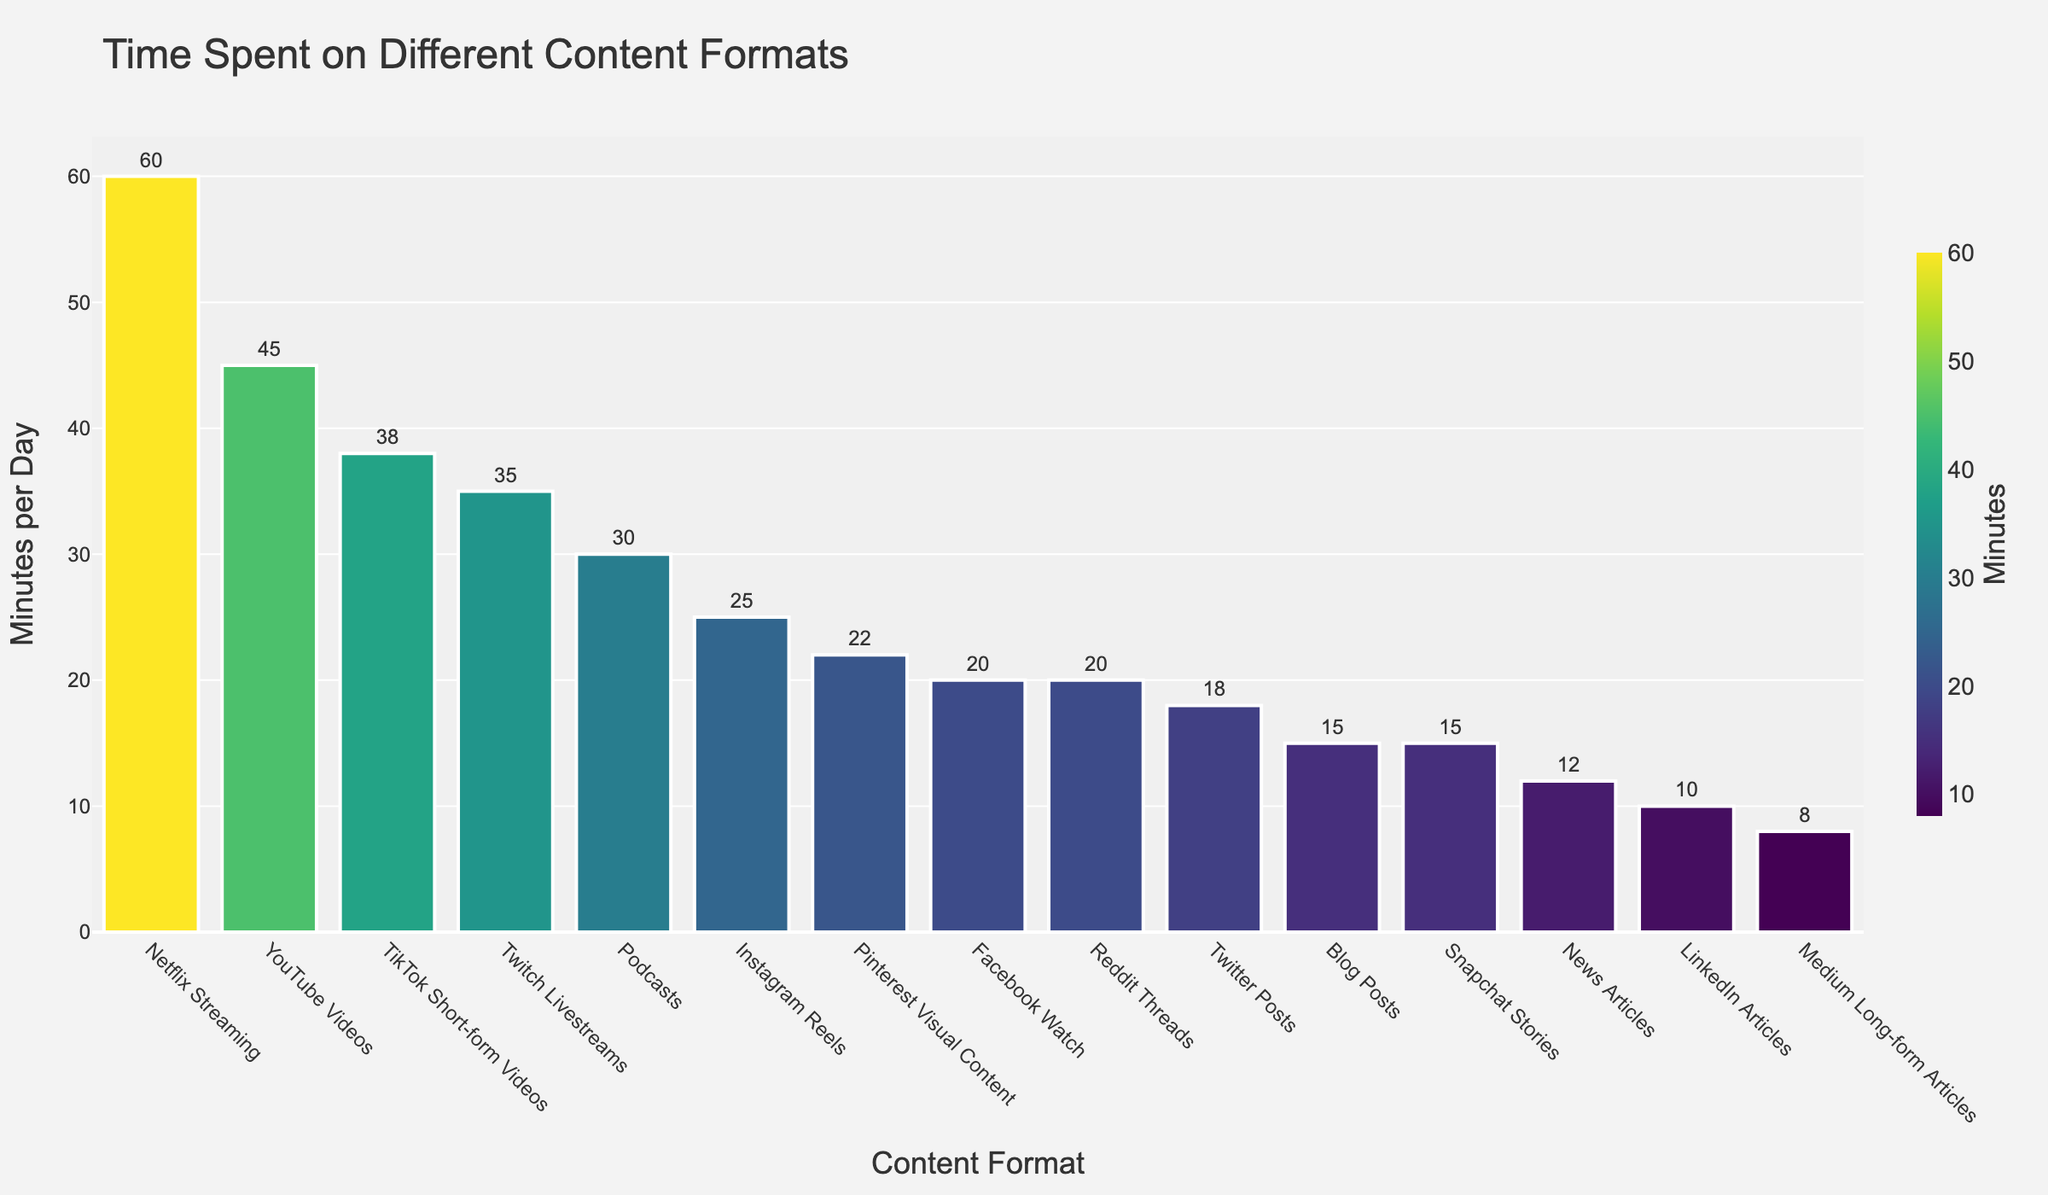How much more time do users spend on Netflix Streaming compared to Blog Posts? To solve this, find the time spent on both types of content formats (Netflix Streaming: 60 minutes, Blog Posts: 15 minutes), then subtract the time spent on Blog Posts from Netflix Streaming: 60 - 15 = 45 minutes.
Answer: 45 minutes Which content format has the second highest average time spent per day? By looking at the bars, Netflix Streaming has the highest time spent at 60 minutes. The next highest bar is YouTube Videos at 45 minutes.
Answer: YouTube Videos What is the sum of average time spent by users on Instagram Reels and Twitter Posts? Find the average time spent on both content formats (Instagram Reels: 25 minutes, Twitter Posts: 18 minutes), then add them together: 25 + 18 = 43 minutes.
Answer: 43 minutes How does the time spent on Podcasts compare to that on TikTok Short-form Videos? Observe the average time spent on both types of content (Podcasts: 30 minutes, TikTok Short-form Videos: 38 minutes). TikTok Short-form Videos have a higher average time spent.
Answer: TikTok Short-form Videos have more time spent What is the average time spent on all video-based content formats listed? The video-based content formats are: YouTube Videos (45 minutes), TikTok Short-form Videos (38 minutes), Instagram Reels (25 minutes), Facebook Watch (20 minutes), Netflix Streaming (60 minutes), and Twitch Livestreams (35 minutes). Add these values up: 45 + 38 + 25 + 20 + 60 + 35 = 223 minutes. Then divide by the number of formats (6): 223 / 6 ≈ 37.17 minutes.
Answer: 37.17 minutes Which content format has the least average time spent per day? By observing the bars, the shortest bar represents Medium Long-form Articles at 8 minutes.
Answer: Medium Long-form Articles Is the average time spent on Pinterest Visual Content higher or lower than that on Facebook Watch? Pinterest Visual Content has an average time spent of 22 minutes, while Facebook Watch has 20 minutes. Thus, Pinterest Visual Content has a higher average time spent.
Answer: Higher By how much does time spent on Snapchat Stories exceed time spent on LinkedIn Articles? Find the time spent on both formats (Snapchat Stories: 15 minutes, LinkedIn Articles: 10 minutes), then subtract the time spent on LinkedIn Articles from Snapchat Stories: 15 - 10 = 5 minutes.
Answer: 5 minutes What is the difference in time spent between the most and least popular content formats? The most popular is Netflix Streaming at 60 minutes, and the least popular is Medium Long-form Articles at 8 minutes. Subtract the least from the most: 60 - 8 = 52 minutes.
Answer: 52 minutes 